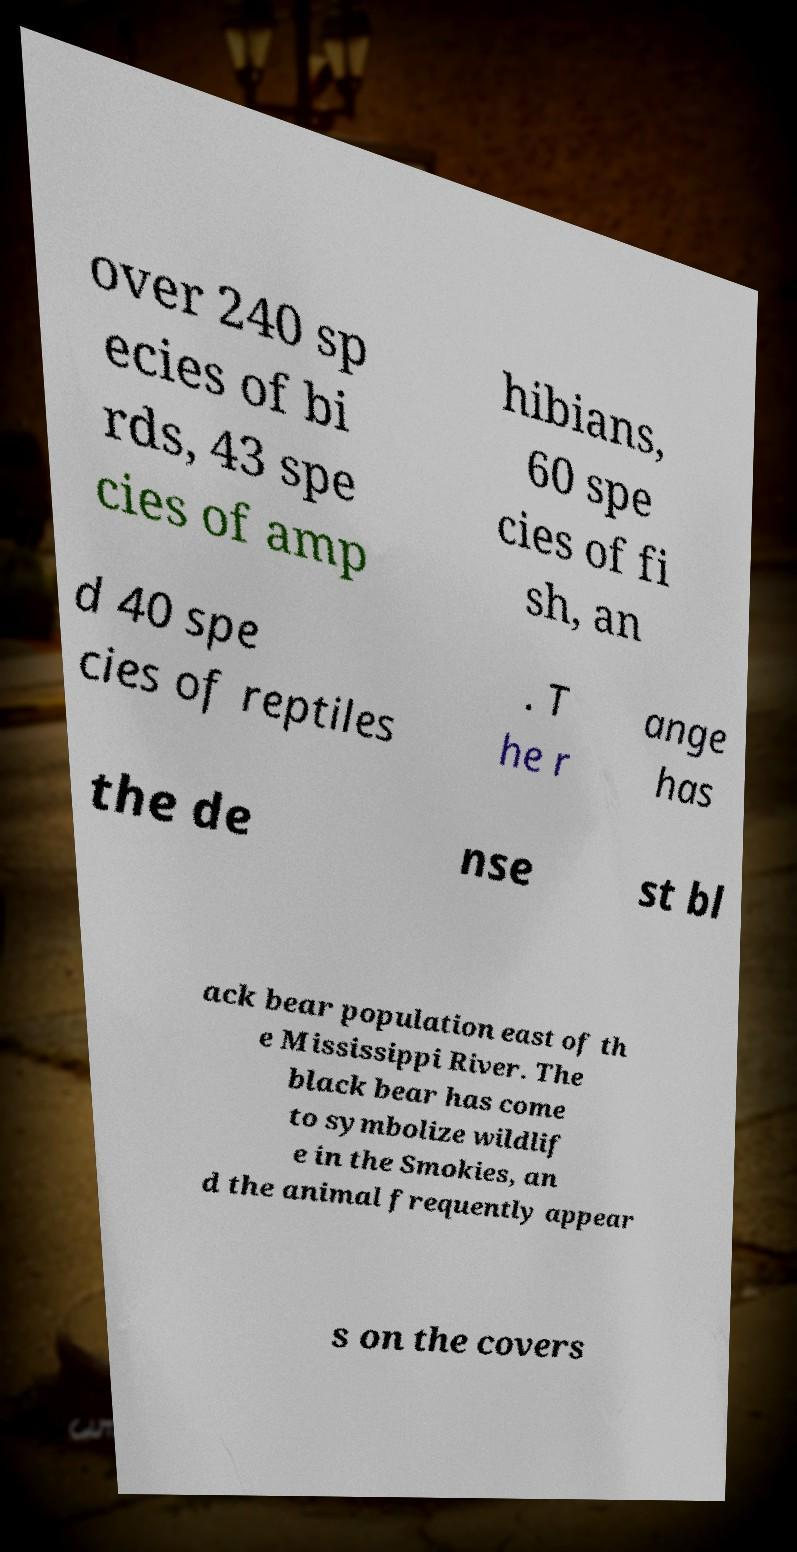What messages or text are displayed in this image? I need them in a readable, typed format. over 240 sp ecies of bi rds, 43 spe cies of amp hibians, 60 spe cies of fi sh, an d 40 spe cies of reptiles . T he r ange has the de nse st bl ack bear population east of th e Mississippi River. The black bear has come to symbolize wildlif e in the Smokies, an d the animal frequently appear s on the covers 